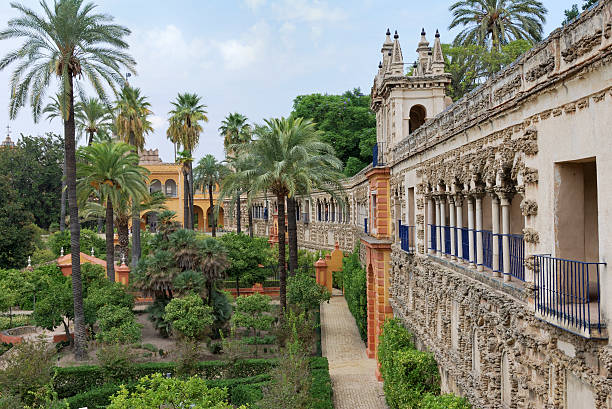Can you tell me about the architectural style visible in this image? Certainly! The image showcases a mixture of architectural styles, with a prominent display of what looks like intricate stonework that has characteristics of the Plateresque style, known for its detailed, ornate, and lavish decorations resembling silversmith's work. This style is typical of the Spanish Renaissance. Additionally, the balustrades and buildings exhibit hints of Moorish influence, with arches and geometric patterns reflecting a historical blend typically found in Southern Spanish architecture. The bright blue railings may have been a later addition, infusing a touch of modernity into the historic scenery. 